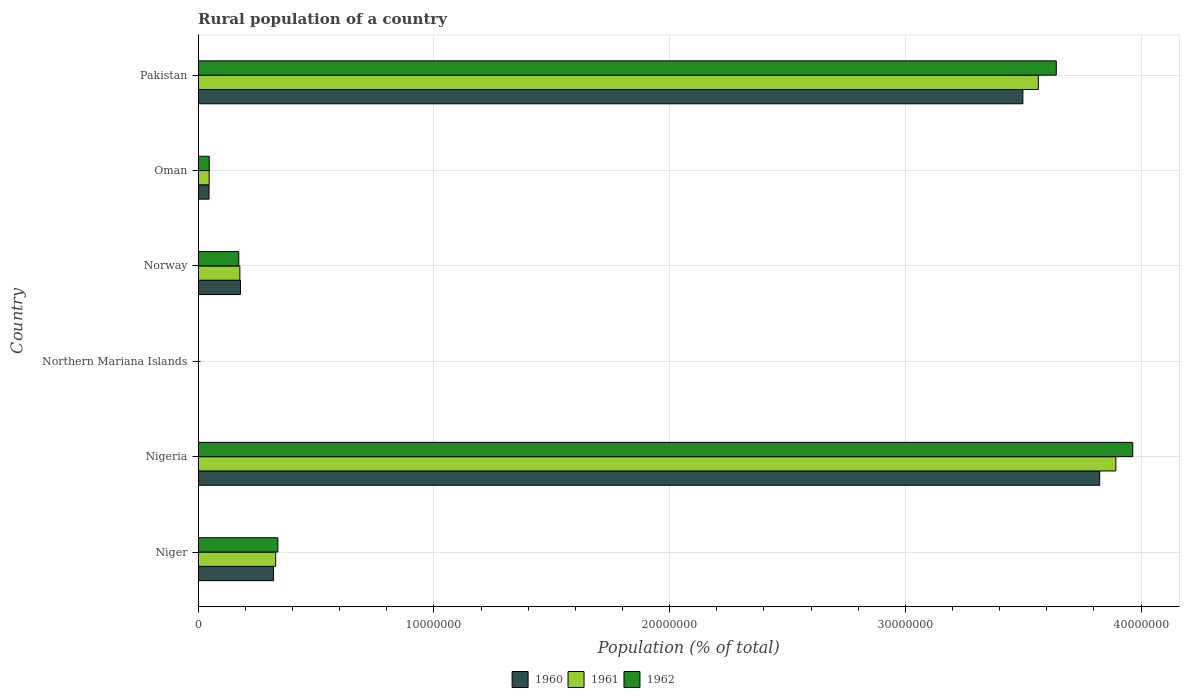How many different coloured bars are there?
Your answer should be compact. 3. Are the number of bars per tick equal to the number of legend labels?
Your answer should be very brief. Yes. How many bars are there on the 2nd tick from the bottom?
Your answer should be very brief. 3. What is the label of the 4th group of bars from the top?
Provide a short and direct response. Northern Mariana Islands. What is the rural population in 1960 in Northern Mariana Islands?
Offer a very short reply. 4912. Across all countries, what is the maximum rural population in 1960?
Ensure brevity in your answer.  3.82e+07. Across all countries, what is the minimum rural population in 1960?
Your response must be concise. 4912. In which country was the rural population in 1962 maximum?
Your response must be concise. Nigeria. In which country was the rural population in 1960 minimum?
Offer a very short reply. Northern Mariana Islands. What is the total rural population in 1961 in the graph?
Keep it short and to the point. 8.01e+07. What is the difference between the rural population in 1960 in Niger and that in Pakistan?
Your answer should be compact. -3.18e+07. What is the difference between the rural population in 1962 in Pakistan and the rural population in 1960 in Oman?
Provide a succinct answer. 3.59e+07. What is the average rural population in 1962 per country?
Your answer should be very brief. 1.36e+07. What is the difference between the rural population in 1961 and rural population in 1960 in Niger?
Make the answer very short. 8.91e+04. In how many countries, is the rural population in 1960 greater than 38000000 %?
Offer a very short reply. 1. What is the ratio of the rural population in 1962 in Nigeria to that in Oman?
Ensure brevity in your answer.  84.15. Is the difference between the rural population in 1961 in Northern Mariana Islands and Norway greater than the difference between the rural population in 1960 in Northern Mariana Islands and Norway?
Offer a very short reply. Yes. What is the difference between the highest and the second highest rural population in 1961?
Provide a short and direct response. 3.29e+06. What is the difference between the highest and the lowest rural population in 1962?
Offer a very short reply. 3.96e+07. In how many countries, is the rural population in 1962 greater than the average rural population in 1962 taken over all countries?
Make the answer very short. 2. What does the 1st bar from the top in Northern Mariana Islands represents?
Your answer should be very brief. 1962. Are all the bars in the graph horizontal?
Keep it short and to the point. Yes. How many countries are there in the graph?
Offer a very short reply. 6. What is the difference between two consecutive major ticks on the X-axis?
Your answer should be very brief. 1.00e+07. Are the values on the major ticks of X-axis written in scientific E-notation?
Provide a succinct answer. No. Where does the legend appear in the graph?
Make the answer very short. Bottom center. How are the legend labels stacked?
Your answer should be very brief. Horizontal. What is the title of the graph?
Your answer should be compact. Rural population of a country. What is the label or title of the X-axis?
Keep it short and to the point. Population (% of total). What is the Population (% of total) in 1960 in Niger?
Offer a very short reply. 3.20e+06. What is the Population (% of total) of 1961 in Niger?
Your response must be concise. 3.29e+06. What is the Population (% of total) of 1962 in Niger?
Provide a succinct answer. 3.38e+06. What is the Population (% of total) in 1960 in Nigeria?
Give a very brief answer. 3.82e+07. What is the Population (% of total) of 1961 in Nigeria?
Your answer should be compact. 3.89e+07. What is the Population (% of total) in 1962 in Nigeria?
Give a very brief answer. 3.96e+07. What is the Population (% of total) of 1960 in Northern Mariana Islands?
Your answer should be very brief. 4912. What is the Population (% of total) in 1961 in Northern Mariana Islands?
Make the answer very short. 4887. What is the Population (% of total) of 1962 in Northern Mariana Islands?
Your answer should be compact. 4821. What is the Population (% of total) in 1960 in Norway?
Offer a very short reply. 1.79e+06. What is the Population (% of total) in 1961 in Norway?
Your response must be concise. 1.77e+06. What is the Population (% of total) in 1962 in Norway?
Your response must be concise. 1.72e+06. What is the Population (% of total) of 1960 in Oman?
Keep it short and to the point. 4.61e+05. What is the Population (% of total) in 1961 in Oman?
Your answer should be compact. 4.66e+05. What is the Population (% of total) of 1962 in Oman?
Your answer should be compact. 4.71e+05. What is the Population (% of total) of 1960 in Pakistan?
Your answer should be very brief. 3.50e+07. What is the Population (% of total) of 1961 in Pakistan?
Your response must be concise. 3.56e+07. What is the Population (% of total) in 1962 in Pakistan?
Offer a terse response. 3.64e+07. Across all countries, what is the maximum Population (% of total) of 1960?
Offer a terse response. 3.82e+07. Across all countries, what is the maximum Population (% of total) of 1961?
Your answer should be very brief. 3.89e+07. Across all countries, what is the maximum Population (% of total) in 1962?
Your response must be concise. 3.96e+07. Across all countries, what is the minimum Population (% of total) of 1960?
Keep it short and to the point. 4912. Across all countries, what is the minimum Population (% of total) in 1961?
Offer a terse response. 4887. Across all countries, what is the minimum Population (% of total) in 1962?
Give a very brief answer. 4821. What is the total Population (% of total) in 1960 in the graph?
Provide a short and direct response. 7.87e+07. What is the total Population (% of total) of 1961 in the graph?
Your answer should be very brief. 8.01e+07. What is the total Population (% of total) in 1962 in the graph?
Offer a very short reply. 8.16e+07. What is the difference between the Population (% of total) in 1960 in Niger and that in Nigeria?
Provide a succinct answer. -3.50e+07. What is the difference between the Population (% of total) in 1961 in Niger and that in Nigeria?
Your response must be concise. -3.56e+07. What is the difference between the Population (% of total) in 1962 in Niger and that in Nigeria?
Provide a short and direct response. -3.63e+07. What is the difference between the Population (% of total) in 1960 in Niger and that in Northern Mariana Islands?
Your answer should be very brief. 3.19e+06. What is the difference between the Population (% of total) in 1961 in Niger and that in Northern Mariana Islands?
Your answer should be very brief. 3.28e+06. What is the difference between the Population (% of total) in 1962 in Niger and that in Northern Mariana Islands?
Your response must be concise. 3.38e+06. What is the difference between the Population (% of total) of 1960 in Niger and that in Norway?
Your answer should be very brief. 1.41e+06. What is the difference between the Population (% of total) of 1961 in Niger and that in Norway?
Make the answer very short. 1.52e+06. What is the difference between the Population (% of total) in 1962 in Niger and that in Norway?
Your response must be concise. 1.66e+06. What is the difference between the Population (% of total) of 1960 in Niger and that in Oman?
Your response must be concise. 2.74e+06. What is the difference between the Population (% of total) in 1961 in Niger and that in Oman?
Provide a succinct answer. 2.82e+06. What is the difference between the Population (% of total) of 1962 in Niger and that in Oman?
Keep it short and to the point. 2.91e+06. What is the difference between the Population (% of total) of 1960 in Niger and that in Pakistan?
Your answer should be compact. -3.18e+07. What is the difference between the Population (% of total) of 1961 in Niger and that in Pakistan?
Offer a terse response. -3.24e+07. What is the difference between the Population (% of total) of 1962 in Niger and that in Pakistan?
Ensure brevity in your answer.  -3.30e+07. What is the difference between the Population (% of total) in 1960 in Nigeria and that in Northern Mariana Islands?
Provide a short and direct response. 3.82e+07. What is the difference between the Population (% of total) of 1961 in Nigeria and that in Northern Mariana Islands?
Offer a terse response. 3.89e+07. What is the difference between the Population (% of total) in 1962 in Nigeria and that in Northern Mariana Islands?
Give a very brief answer. 3.96e+07. What is the difference between the Population (% of total) of 1960 in Nigeria and that in Norway?
Make the answer very short. 3.65e+07. What is the difference between the Population (% of total) in 1961 in Nigeria and that in Norway?
Your answer should be compact. 3.72e+07. What is the difference between the Population (% of total) in 1962 in Nigeria and that in Norway?
Your response must be concise. 3.79e+07. What is the difference between the Population (% of total) of 1960 in Nigeria and that in Oman?
Provide a short and direct response. 3.78e+07. What is the difference between the Population (% of total) in 1961 in Nigeria and that in Oman?
Ensure brevity in your answer.  3.85e+07. What is the difference between the Population (% of total) of 1962 in Nigeria and that in Oman?
Give a very brief answer. 3.92e+07. What is the difference between the Population (% of total) in 1960 in Nigeria and that in Pakistan?
Your response must be concise. 3.26e+06. What is the difference between the Population (% of total) of 1961 in Nigeria and that in Pakistan?
Your answer should be compact. 3.29e+06. What is the difference between the Population (% of total) of 1962 in Nigeria and that in Pakistan?
Give a very brief answer. 3.24e+06. What is the difference between the Population (% of total) of 1960 in Northern Mariana Islands and that in Norway?
Provide a short and direct response. -1.79e+06. What is the difference between the Population (% of total) of 1961 in Northern Mariana Islands and that in Norway?
Keep it short and to the point. -1.76e+06. What is the difference between the Population (% of total) in 1962 in Northern Mariana Islands and that in Norway?
Your response must be concise. -1.72e+06. What is the difference between the Population (% of total) of 1960 in Northern Mariana Islands and that in Oman?
Ensure brevity in your answer.  -4.56e+05. What is the difference between the Population (% of total) in 1961 in Northern Mariana Islands and that in Oman?
Offer a terse response. -4.61e+05. What is the difference between the Population (% of total) in 1962 in Northern Mariana Islands and that in Oman?
Provide a succinct answer. -4.66e+05. What is the difference between the Population (% of total) of 1960 in Northern Mariana Islands and that in Pakistan?
Keep it short and to the point. -3.50e+07. What is the difference between the Population (% of total) of 1961 in Northern Mariana Islands and that in Pakistan?
Provide a short and direct response. -3.56e+07. What is the difference between the Population (% of total) of 1962 in Northern Mariana Islands and that in Pakistan?
Make the answer very short. -3.64e+07. What is the difference between the Population (% of total) in 1960 in Norway and that in Oman?
Your response must be concise. 1.33e+06. What is the difference between the Population (% of total) of 1961 in Norway and that in Oman?
Your response must be concise. 1.30e+06. What is the difference between the Population (% of total) in 1962 in Norway and that in Oman?
Offer a very short reply. 1.25e+06. What is the difference between the Population (% of total) in 1960 in Norway and that in Pakistan?
Provide a succinct answer. -3.32e+07. What is the difference between the Population (% of total) of 1961 in Norway and that in Pakistan?
Offer a very short reply. -3.39e+07. What is the difference between the Population (% of total) in 1962 in Norway and that in Pakistan?
Your answer should be compact. -3.47e+07. What is the difference between the Population (% of total) in 1960 in Oman and that in Pakistan?
Offer a terse response. -3.45e+07. What is the difference between the Population (% of total) in 1961 in Oman and that in Pakistan?
Make the answer very short. -3.52e+07. What is the difference between the Population (% of total) in 1962 in Oman and that in Pakistan?
Ensure brevity in your answer.  -3.59e+07. What is the difference between the Population (% of total) of 1960 in Niger and the Population (% of total) of 1961 in Nigeria?
Your answer should be very brief. -3.57e+07. What is the difference between the Population (% of total) in 1960 in Niger and the Population (% of total) in 1962 in Nigeria?
Provide a short and direct response. -3.64e+07. What is the difference between the Population (% of total) in 1961 in Niger and the Population (% of total) in 1962 in Nigeria?
Give a very brief answer. -3.64e+07. What is the difference between the Population (% of total) in 1960 in Niger and the Population (% of total) in 1961 in Northern Mariana Islands?
Your answer should be compact. 3.19e+06. What is the difference between the Population (% of total) in 1960 in Niger and the Population (% of total) in 1962 in Northern Mariana Islands?
Ensure brevity in your answer.  3.19e+06. What is the difference between the Population (% of total) of 1961 in Niger and the Population (% of total) of 1962 in Northern Mariana Islands?
Your answer should be very brief. 3.28e+06. What is the difference between the Population (% of total) of 1960 in Niger and the Population (% of total) of 1961 in Norway?
Make the answer very short. 1.43e+06. What is the difference between the Population (% of total) in 1960 in Niger and the Population (% of total) in 1962 in Norway?
Provide a succinct answer. 1.48e+06. What is the difference between the Population (% of total) of 1961 in Niger and the Population (% of total) of 1962 in Norway?
Offer a terse response. 1.56e+06. What is the difference between the Population (% of total) in 1960 in Niger and the Population (% of total) in 1961 in Oman?
Your answer should be very brief. 2.73e+06. What is the difference between the Population (% of total) in 1960 in Niger and the Population (% of total) in 1962 in Oman?
Give a very brief answer. 2.73e+06. What is the difference between the Population (% of total) of 1961 in Niger and the Population (% of total) of 1962 in Oman?
Keep it short and to the point. 2.82e+06. What is the difference between the Population (% of total) in 1960 in Niger and the Population (% of total) in 1961 in Pakistan?
Provide a short and direct response. -3.24e+07. What is the difference between the Population (% of total) in 1960 in Niger and the Population (% of total) in 1962 in Pakistan?
Your response must be concise. -3.32e+07. What is the difference between the Population (% of total) of 1961 in Niger and the Population (% of total) of 1962 in Pakistan?
Your answer should be compact. -3.31e+07. What is the difference between the Population (% of total) in 1960 in Nigeria and the Population (% of total) in 1961 in Northern Mariana Islands?
Ensure brevity in your answer.  3.82e+07. What is the difference between the Population (% of total) of 1960 in Nigeria and the Population (% of total) of 1962 in Northern Mariana Islands?
Your answer should be compact. 3.82e+07. What is the difference between the Population (% of total) in 1961 in Nigeria and the Population (% of total) in 1962 in Northern Mariana Islands?
Offer a very short reply. 3.89e+07. What is the difference between the Population (% of total) of 1960 in Nigeria and the Population (% of total) of 1961 in Norway?
Offer a terse response. 3.65e+07. What is the difference between the Population (% of total) of 1960 in Nigeria and the Population (% of total) of 1962 in Norway?
Your response must be concise. 3.65e+07. What is the difference between the Population (% of total) of 1961 in Nigeria and the Population (% of total) of 1962 in Norway?
Offer a very short reply. 3.72e+07. What is the difference between the Population (% of total) in 1960 in Nigeria and the Population (% of total) in 1961 in Oman?
Make the answer very short. 3.78e+07. What is the difference between the Population (% of total) of 1960 in Nigeria and the Population (% of total) of 1962 in Oman?
Offer a very short reply. 3.78e+07. What is the difference between the Population (% of total) in 1961 in Nigeria and the Population (% of total) in 1962 in Oman?
Provide a short and direct response. 3.85e+07. What is the difference between the Population (% of total) in 1960 in Nigeria and the Population (% of total) in 1961 in Pakistan?
Make the answer very short. 2.60e+06. What is the difference between the Population (% of total) in 1960 in Nigeria and the Population (% of total) in 1962 in Pakistan?
Offer a terse response. 1.84e+06. What is the difference between the Population (% of total) in 1961 in Nigeria and the Population (% of total) in 1962 in Pakistan?
Give a very brief answer. 2.53e+06. What is the difference between the Population (% of total) of 1960 in Northern Mariana Islands and the Population (% of total) of 1961 in Norway?
Make the answer very short. -1.76e+06. What is the difference between the Population (% of total) in 1960 in Northern Mariana Islands and the Population (% of total) in 1962 in Norway?
Give a very brief answer. -1.72e+06. What is the difference between the Population (% of total) of 1961 in Northern Mariana Islands and the Population (% of total) of 1962 in Norway?
Your response must be concise. -1.72e+06. What is the difference between the Population (% of total) of 1960 in Northern Mariana Islands and the Population (% of total) of 1961 in Oman?
Offer a terse response. -4.61e+05. What is the difference between the Population (% of total) in 1960 in Northern Mariana Islands and the Population (% of total) in 1962 in Oman?
Provide a succinct answer. -4.66e+05. What is the difference between the Population (% of total) in 1961 in Northern Mariana Islands and the Population (% of total) in 1962 in Oman?
Offer a very short reply. -4.66e+05. What is the difference between the Population (% of total) in 1960 in Northern Mariana Islands and the Population (% of total) in 1961 in Pakistan?
Provide a succinct answer. -3.56e+07. What is the difference between the Population (% of total) of 1960 in Northern Mariana Islands and the Population (% of total) of 1962 in Pakistan?
Keep it short and to the point. -3.64e+07. What is the difference between the Population (% of total) in 1961 in Northern Mariana Islands and the Population (% of total) in 1962 in Pakistan?
Ensure brevity in your answer.  -3.64e+07. What is the difference between the Population (% of total) of 1960 in Norway and the Population (% of total) of 1961 in Oman?
Your response must be concise. 1.33e+06. What is the difference between the Population (% of total) of 1960 in Norway and the Population (% of total) of 1962 in Oman?
Your response must be concise. 1.32e+06. What is the difference between the Population (% of total) of 1961 in Norway and the Population (% of total) of 1962 in Oman?
Your answer should be compact. 1.30e+06. What is the difference between the Population (% of total) of 1960 in Norway and the Population (% of total) of 1961 in Pakistan?
Your response must be concise. -3.38e+07. What is the difference between the Population (% of total) of 1960 in Norway and the Population (% of total) of 1962 in Pakistan?
Ensure brevity in your answer.  -3.46e+07. What is the difference between the Population (% of total) in 1961 in Norway and the Population (% of total) in 1962 in Pakistan?
Provide a succinct answer. -3.46e+07. What is the difference between the Population (% of total) in 1960 in Oman and the Population (% of total) in 1961 in Pakistan?
Your answer should be very brief. -3.52e+07. What is the difference between the Population (% of total) in 1960 in Oman and the Population (% of total) in 1962 in Pakistan?
Give a very brief answer. -3.59e+07. What is the difference between the Population (% of total) in 1961 in Oman and the Population (% of total) in 1962 in Pakistan?
Give a very brief answer. -3.59e+07. What is the average Population (% of total) in 1960 per country?
Your answer should be very brief. 1.31e+07. What is the average Population (% of total) of 1961 per country?
Offer a very short reply. 1.33e+07. What is the average Population (% of total) in 1962 per country?
Provide a short and direct response. 1.36e+07. What is the difference between the Population (% of total) in 1960 and Population (% of total) in 1961 in Niger?
Offer a very short reply. -8.91e+04. What is the difference between the Population (% of total) of 1960 and Population (% of total) of 1962 in Niger?
Make the answer very short. -1.82e+05. What is the difference between the Population (% of total) of 1961 and Population (% of total) of 1962 in Niger?
Offer a terse response. -9.32e+04. What is the difference between the Population (% of total) of 1960 and Population (% of total) of 1961 in Nigeria?
Your answer should be very brief. -6.86e+05. What is the difference between the Population (% of total) of 1960 and Population (% of total) of 1962 in Nigeria?
Give a very brief answer. -1.40e+06. What is the difference between the Population (% of total) in 1961 and Population (% of total) in 1962 in Nigeria?
Ensure brevity in your answer.  -7.15e+05. What is the difference between the Population (% of total) in 1960 and Population (% of total) in 1962 in Northern Mariana Islands?
Make the answer very short. 91. What is the difference between the Population (% of total) of 1960 and Population (% of total) of 1961 in Norway?
Your answer should be very brief. 2.46e+04. What is the difference between the Population (% of total) of 1960 and Population (% of total) of 1962 in Norway?
Offer a terse response. 7.06e+04. What is the difference between the Population (% of total) in 1961 and Population (% of total) in 1962 in Norway?
Your answer should be very brief. 4.60e+04. What is the difference between the Population (% of total) of 1960 and Population (% of total) of 1961 in Oman?
Offer a very short reply. -4928. What is the difference between the Population (% of total) of 1960 and Population (% of total) of 1962 in Oman?
Ensure brevity in your answer.  -9871. What is the difference between the Population (% of total) in 1961 and Population (% of total) in 1962 in Oman?
Your answer should be compact. -4943. What is the difference between the Population (% of total) of 1960 and Population (% of total) of 1961 in Pakistan?
Your answer should be compact. -6.56e+05. What is the difference between the Population (% of total) of 1960 and Population (% of total) of 1962 in Pakistan?
Your answer should be compact. -1.42e+06. What is the difference between the Population (% of total) of 1961 and Population (% of total) of 1962 in Pakistan?
Keep it short and to the point. -7.61e+05. What is the ratio of the Population (% of total) in 1960 in Niger to that in Nigeria?
Make the answer very short. 0.08. What is the ratio of the Population (% of total) in 1961 in Niger to that in Nigeria?
Provide a short and direct response. 0.08. What is the ratio of the Population (% of total) of 1962 in Niger to that in Nigeria?
Offer a terse response. 0.09. What is the ratio of the Population (% of total) in 1960 in Niger to that in Northern Mariana Islands?
Offer a very short reply. 651.17. What is the ratio of the Population (% of total) in 1961 in Niger to that in Northern Mariana Islands?
Your answer should be compact. 672.73. What is the ratio of the Population (% of total) in 1962 in Niger to that in Northern Mariana Islands?
Ensure brevity in your answer.  701.27. What is the ratio of the Population (% of total) in 1960 in Niger to that in Norway?
Provide a short and direct response. 1.78. What is the ratio of the Population (% of total) of 1961 in Niger to that in Norway?
Offer a very short reply. 1.86. What is the ratio of the Population (% of total) of 1962 in Niger to that in Norway?
Make the answer very short. 1.96. What is the ratio of the Population (% of total) in 1960 in Niger to that in Oman?
Ensure brevity in your answer.  6.93. What is the ratio of the Population (% of total) in 1961 in Niger to that in Oman?
Provide a succinct answer. 7.05. What is the ratio of the Population (% of total) of 1962 in Niger to that in Oman?
Offer a terse response. 7.18. What is the ratio of the Population (% of total) in 1960 in Niger to that in Pakistan?
Your response must be concise. 0.09. What is the ratio of the Population (% of total) in 1961 in Niger to that in Pakistan?
Your answer should be compact. 0.09. What is the ratio of the Population (% of total) in 1962 in Niger to that in Pakistan?
Make the answer very short. 0.09. What is the ratio of the Population (% of total) in 1960 in Nigeria to that in Northern Mariana Islands?
Provide a short and direct response. 7785.93. What is the ratio of the Population (% of total) of 1961 in Nigeria to that in Northern Mariana Islands?
Your answer should be very brief. 7966.12. What is the ratio of the Population (% of total) of 1962 in Nigeria to that in Northern Mariana Islands?
Give a very brief answer. 8223.59. What is the ratio of the Population (% of total) of 1960 in Nigeria to that in Norway?
Offer a very short reply. 21.32. What is the ratio of the Population (% of total) of 1961 in Nigeria to that in Norway?
Ensure brevity in your answer.  22.01. What is the ratio of the Population (% of total) in 1962 in Nigeria to that in Norway?
Provide a succinct answer. 23.01. What is the ratio of the Population (% of total) in 1960 in Nigeria to that in Oman?
Provide a succinct answer. 82.91. What is the ratio of the Population (% of total) in 1961 in Nigeria to that in Oman?
Make the answer very short. 83.51. What is the ratio of the Population (% of total) of 1962 in Nigeria to that in Oman?
Make the answer very short. 84.15. What is the ratio of the Population (% of total) in 1960 in Nigeria to that in Pakistan?
Provide a succinct answer. 1.09. What is the ratio of the Population (% of total) in 1961 in Nigeria to that in Pakistan?
Provide a succinct answer. 1.09. What is the ratio of the Population (% of total) in 1962 in Nigeria to that in Pakistan?
Give a very brief answer. 1.09. What is the ratio of the Population (% of total) in 1960 in Northern Mariana Islands to that in Norway?
Offer a very short reply. 0. What is the ratio of the Population (% of total) in 1961 in Northern Mariana Islands to that in Norway?
Make the answer very short. 0. What is the ratio of the Population (% of total) of 1962 in Northern Mariana Islands to that in Norway?
Offer a very short reply. 0. What is the ratio of the Population (% of total) in 1960 in Northern Mariana Islands to that in Oman?
Offer a very short reply. 0.01. What is the ratio of the Population (% of total) of 1961 in Northern Mariana Islands to that in Oman?
Give a very brief answer. 0.01. What is the ratio of the Population (% of total) of 1962 in Northern Mariana Islands to that in Oman?
Ensure brevity in your answer.  0.01. What is the ratio of the Population (% of total) in 1960 in Northern Mariana Islands to that in Pakistan?
Ensure brevity in your answer.  0. What is the ratio of the Population (% of total) in 1962 in Northern Mariana Islands to that in Pakistan?
Provide a short and direct response. 0. What is the ratio of the Population (% of total) of 1960 in Norway to that in Oman?
Make the answer very short. 3.89. What is the ratio of the Population (% of total) in 1961 in Norway to that in Oman?
Provide a succinct answer. 3.79. What is the ratio of the Population (% of total) of 1962 in Norway to that in Oman?
Provide a short and direct response. 3.66. What is the ratio of the Population (% of total) in 1960 in Norway to that in Pakistan?
Ensure brevity in your answer.  0.05. What is the ratio of the Population (% of total) of 1961 in Norway to that in Pakistan?
Your response must be concise. 0.05. What is the ratio of the Population (% of total) in 1962 in Norway to that in Pakistan?
Ensure brevity in your answer.  0.05. What is the ratio of the Population (% of total) of 1960 in Oman to that in Pakistan?
Your answer should be very brief. 0.01. What is the ratio of the Population (% of total) of 1961 in Oman to that in Pakistan?
Provide a short and direct response. 0.01. What is the ratio of the Population (% of total) of 1962 in Oman to that in Pakistan?
Offer a terse response. 0.01. What is the difference between the highest and the second highest Population (% of total) of 1960?
Keep it short and to the point. 3.26e+06. What is the difference between the highest and the second highest Population (% of total) in 1961?
Your response must be concise. 3.29e+06. What is the difference between the highest and the second highest Population (% of total) of 1962?
Offer a very short reply. 3.24e+06. What is the difference between the highest and the lowest Population (% of total) in 1960?
Offer a very short reply. 3.82e+07. What is the difference between the highest and the lowest Population (% of total) of 1961?
Make the answer very short. 3.89e+07. What is the difference between the highest and the lowest Population (% of total) in 1962?
Provide a short and direct response. 3.96e+07. 